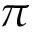<formula> <loc_0><loc_0><loc_500><loc_500>\pi</formula> 